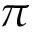<formula> <loc_0><loc_0><loc_500><loc_500>\pi</formula> 